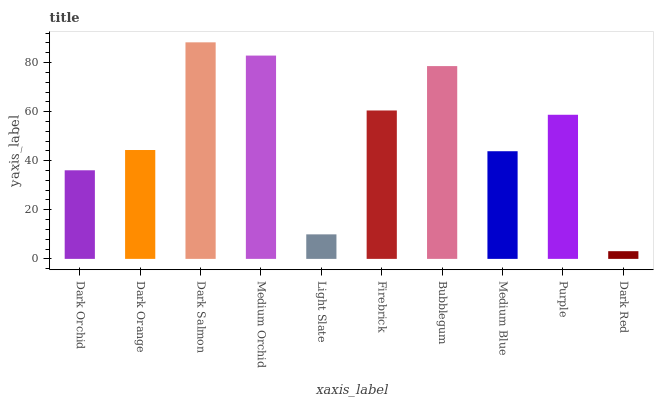Is Dark Red the minimum?
Answer yes or no. Yes. Is Dark Salmon the maximum?
Answer yes or no. Yes. Is Dark Orange the minimum?
Answer yes or no. No. Is Dark Orange the maximum?
Answer yes or no. No. Is Dark Orange greater than Dark Orchid?
Answer yes or no. Yes. Is Dark Orchid less than Dark Orange?
Answer yes or no. Yes. Is Dark Orchid greater than Dark Orange?
Answer yes or no. No. Is Dark Orange less than Dark Orchid?
Answer yes or no. No. Is Purple the high median?
Answer yes or no. Yes. Is Dark Orange the low median?
Answer yes or no. Yes. Is Dark Red the high median?
Answer yes or no. No. Is Purple the low median?
Answer yes or no. No. 